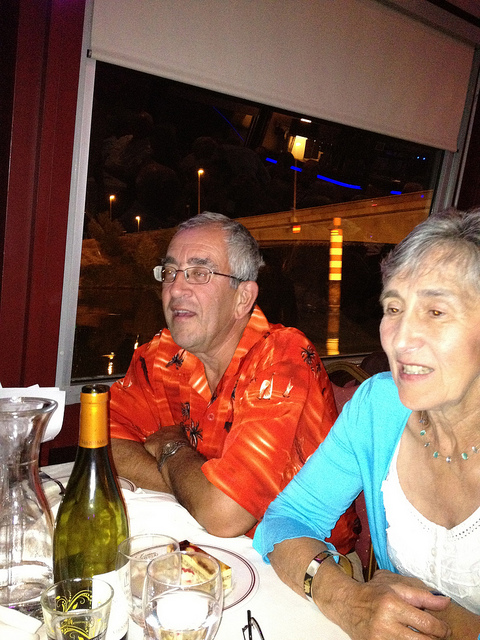Imagine if the man in the image had a secret identity, what could it be? What if the man in the orange Hawaiian shirt is actually a retired secret agent? Known only by his code name, 'The Phoenix,' he spent years thwarting international plots. Now in his retirement, he's taken on the guise of an ordinary, cheerful senior, recounting his 'sailor' stories, which are actually cryptic anecdotes from his espionage days, understood only by his old comrades. 